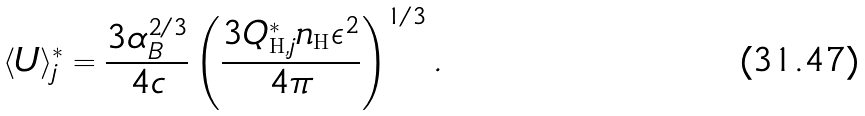Convert formula to latex. <formula><loc_0><loc_0><loc_500><loc_500>\langle U \rangle ^ { * } _ { j } = \frac { 3 \alpha _ { B } ^ { 2 / 3 } } { 4 c } \left ( \frac { 3 Q ^ { * } _ { { \mathrm H } , j } n _ { \mathrm H } \epsilon ^ { 2 } } { 4 \pi } \right ) ^ { 1 / 3 } .</formula> 